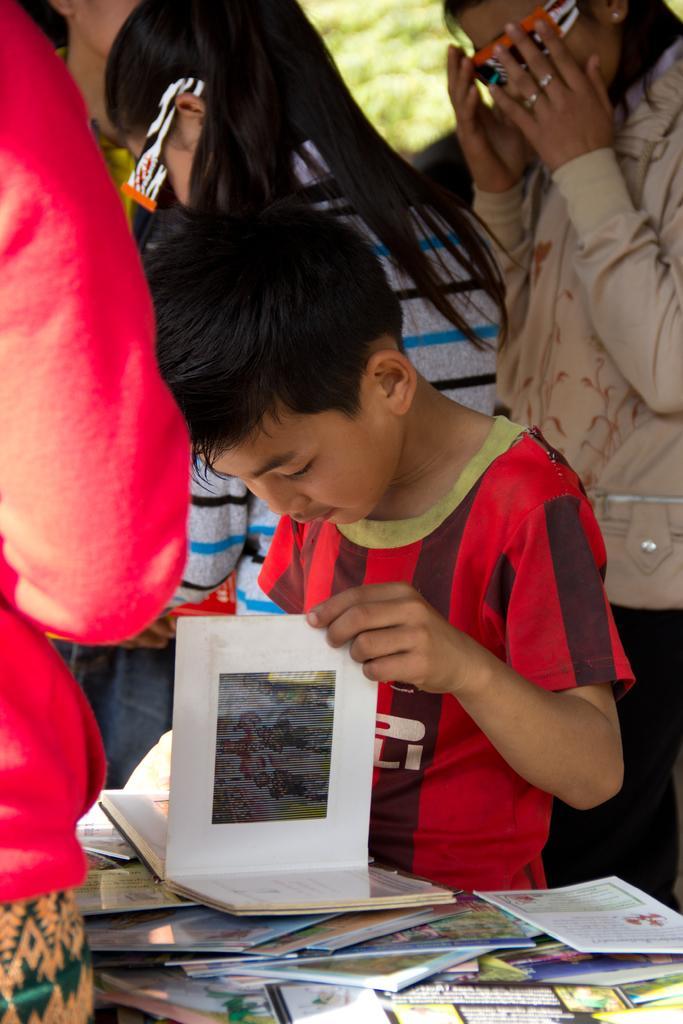How would you summarize this image in a sentence or two? In this picture we can see few people, in the middle of the image we can see a boy, he is holding a book, in front of him we can find few more books. 